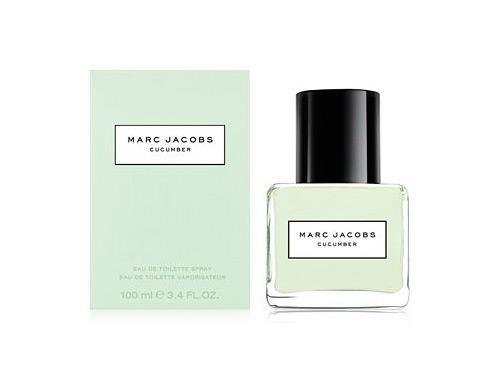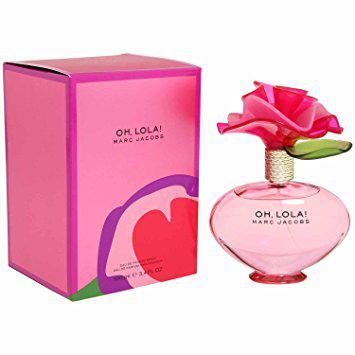The first image is the image on the left, the second image is the image on the right. Considering the images on both sides, is "A perfume bottle in one image is topped with a decorative cap that is covered with plastic daisies." valid? Answer yes or no. No. 